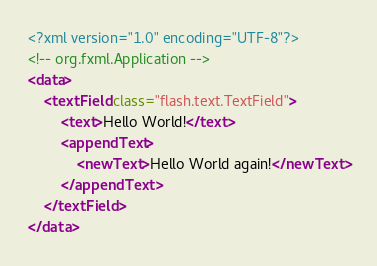Convert code to text. <code><loc_0><loc_0><loc_500><loc_500><_XML_><?xml version="1.0" encoding="UTF-8"?>
<!-- org.fxml.Application -->
<data>
	<textField class="flash.text.TextField">
		<text>Hello World!</text>
		<appendText>
			<newText>Hello World again!</newText>
		</appendText>
	</textField>
</data>


</code> 